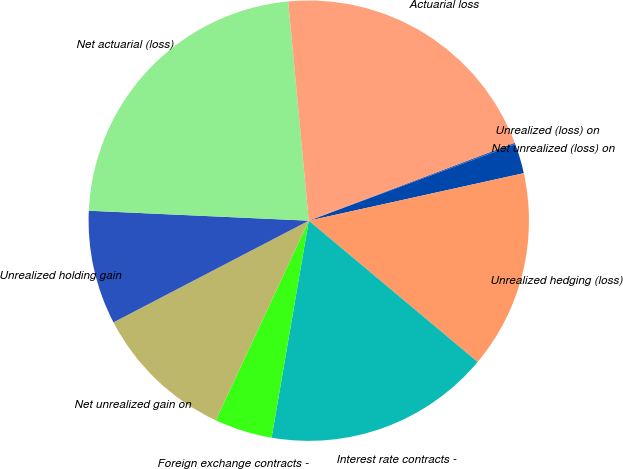Convert chart to OTSL. <chart><loc_0><loc_0><loc_500><loc_500><pie_chart><fcel>Unrealized (loss) on<fcel>Net unrealized (loss) on<fcel>Unrealized hedging (loss)<fcel>Interest rate contracts -<fcel>Foreign exchange contracts -<fcel>Net unrealized gain on<fcel>Unrealized holding gain<fcel>Net actuarial (loss)<fcel>Actuarial loss<nl><fcel>0.12%<fcel>2.18%<fcel>14.55%<fcel>16.61%<fcel>4.24%<fcel>10.42%<fcel>8.36%<fcel>22.79%<fcel>20.73%<nl></chart> 